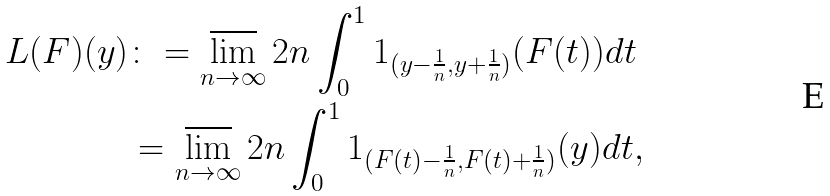<formula> <loc_0><loc_0><loc_500><loc_500>L ( F ) ( y ) & \colon = \varlimsup _ { n \to \infty } 2 n \int _ { 0 } ^ { 1 } 1 _ { ( y - \frac { 1 } { n } , y + \frac { 1 } { n } ) } ( F ( t ) ) d t \\ & = \varlimsup _ { n \to \infty } 2 n \int _ { 0 } ^ { 1 } 1 _ { ( F ( t ) - \frac { 1 } { n } , F ( t ) + \frac { 1 } { n } ) } ( y ) d t ,</formula> 